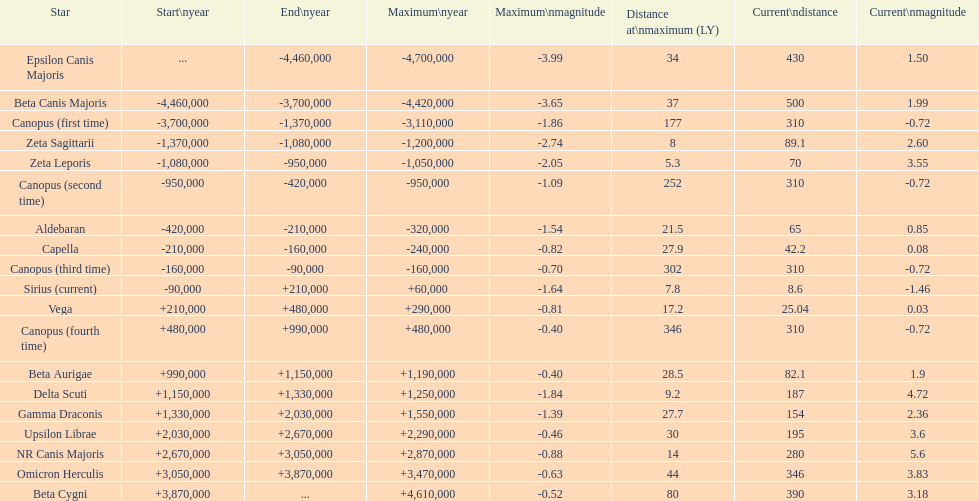How many stars do not have a current magnitude greater than zero? 5. 